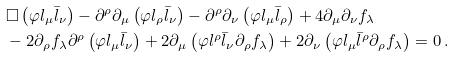<formula> <loc_0><loc_0><loc_500><loc_500>& \Box \left ( \varphi l _ { \mu } \bar { l } _ { \nu } \right ) - \partial ^ { \rho } \partial _ { \mu } \left ( \varphi l _ { \rho } \bar { l } _ { \nu } \right ) - \partial ^ { \rho } \partial _ { \nu } \left ( \varphi l _ { \mu } \bar { l } _ { \rho } \right ) + 4 \partial _ { \mu } \partial _ { \nu } f _ { \lambda } \\ & - 2 \partial _ { \rho } f _ { \lambda } \partial ^ { \rho } \left ( \varphi l _ { \mu } \bar { l } _ { \nu } \right ) + 2 \partial _ { \mu } \left ( \varphi l ^ { \rho } \bar { l } _ { \nu } \partial _ { \rho } f _ { \lambda } \right ) + 2 \partial _ { \nu } \left ( \varphi l _ { \mu } \bar { l } ^ { \rho } \partial _ { \rho } f _ { \lambda } \right ) = 0 \, .</formula> 